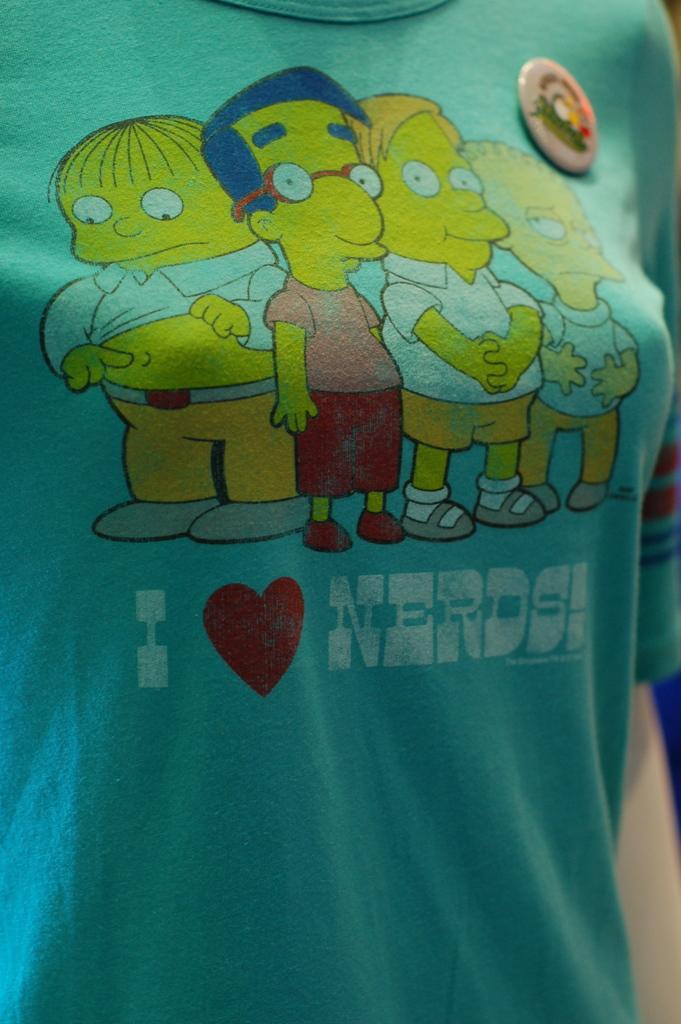Could you give a brief overview of what you see in this image? Here in this picture we can see a T shirt present, on which we can see some text present and some animated cartoons present over there. 